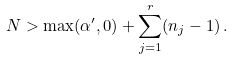Convert formula to latex. <formula><loc_0><loc_0><loc_500><loc_500>N > \max ( \alpha ^ { \prime } , 0 ) + \sum _ { j = 1 } ^ { r } ( n _ { j } - 1 ) \, .</formula> 